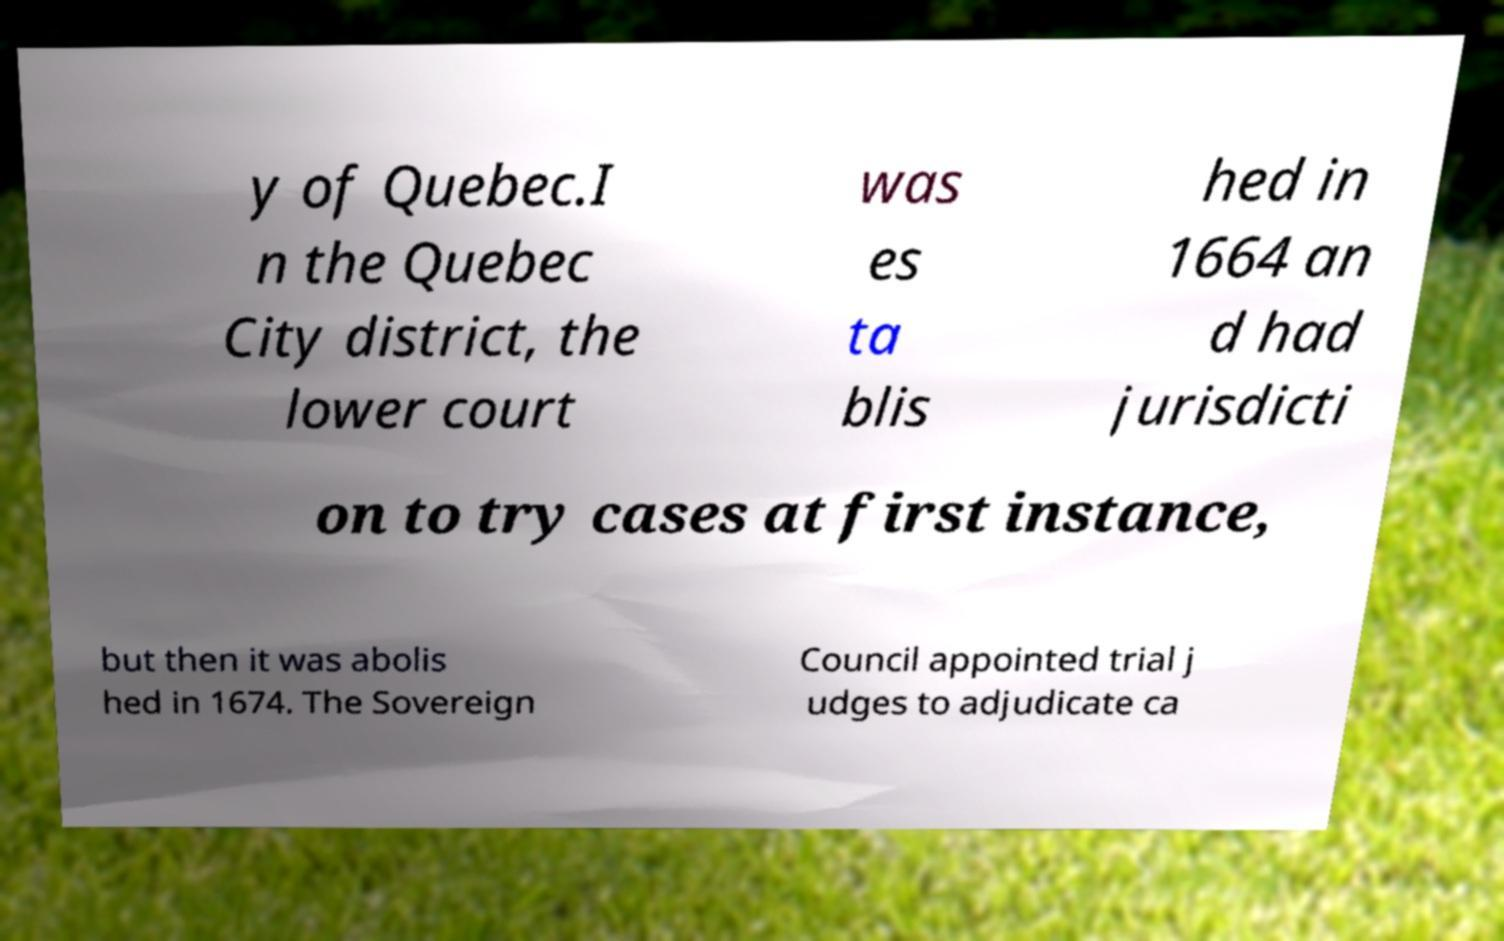Please identify and transcribe the text found in this image. y of Quebec.I n the Quebec City district, the lower court was es ta blis hed in 1664 an d had jurisdicti on to try cases at first instance, but then it was abolis hed in 1674. The Sovereign Council appointed trial j udges to adjudicate ca 